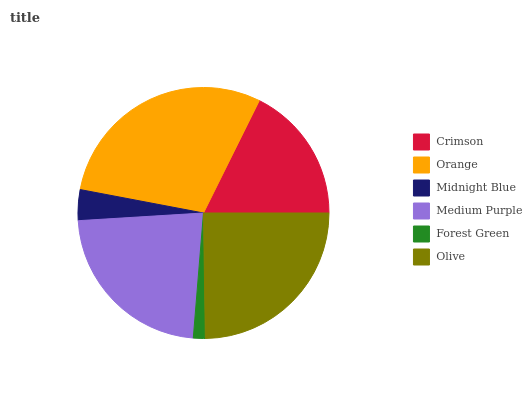Is Forest Green the minimum?
Answer yes or no. Yes. Is Orange the maximum?
Answer yes or no. Yes. Is Midnight Blue the minimum?
Answer yes or no. No. Is Midnight Blue the maximum?
Answer yes or no. No. Is Orange greater than Midnight Blue?
Answer yes or no. Yes. Is Midnight Blue less than Orange?
Answer yes or no. Yes. Is Midnight Blue greater than Orange?
Answer yes or no. No. Is Orange less than Midnight Blue?
Answer yes or no. No. Is Medium Purple the high median?
Answer yes or no. Yes. Is Crimson the low median?
Answer yes or no. Yes. Is Midnight Blue the high median?
Answer yes or no. No. Is Midnight Blue the low median?
Answer yes or no. No. 